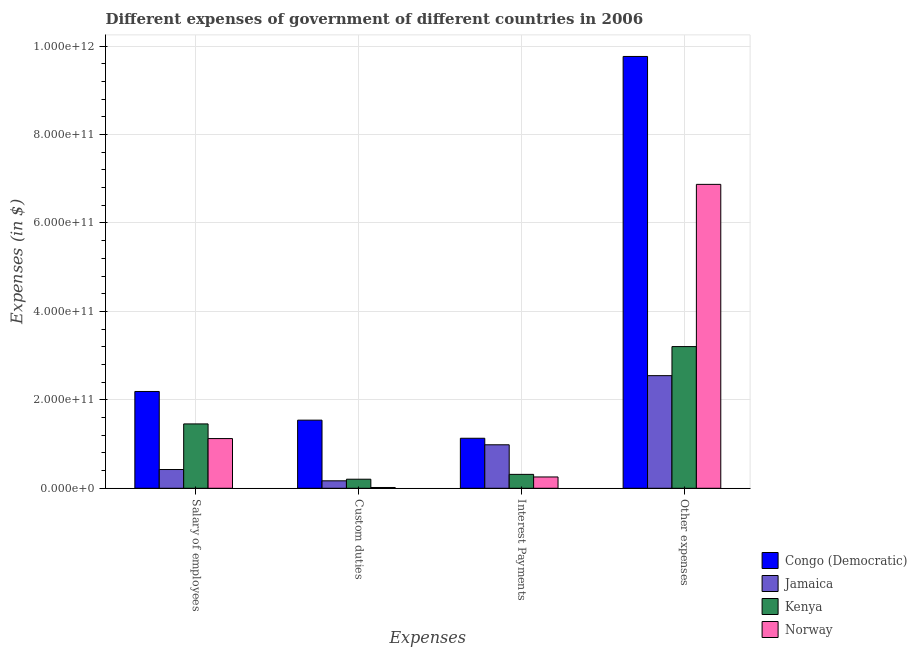Are the number of bars per tick equal to the number of legend labels?
Provide a short and direct response. Yes. How many bars are there on the 4th tick from the left?
Your response must be concise. 4. How many bars are there on the 4th tick from the right?
Keep it short and to the point. 4. What is the label of the 4th group of bars from the left?
Ensure brevity in your answer.  Other expenses. What is the amount spent on salary of employees in Norway?
Your answer should be compact. 1.12e+11. Across all countries, what is the maximum amount spent on interest payments?
Offer a very short reply. 1.13e+11. Across all countries, what is the minimum amount spent on other expenses?
Your response must be concise. 2.55e+11. In which country was the amount spent on custom duties maximum?
Your response must be concise. Congo (Democratic). What is the total amount spent on other expenses in the graph?
Give a very brief answer. 2.24e+12. What is the difference between the amount spent on interest payments in Congo (Democratic) and that in Norway?
Your response must be concise. 8.75e+1. What is the difference between the amount spent on other expenses in Kenya and the amount spent on interest payments in Norway?
Provide a succinct answer. 2.95e+11. What is the average amount spent on other expenses per country?
Offer a terse response. 5.60e+11. What is the difference between the amount spent on custom duties and amount spent on interest payments in Jamaica?
Make the answer very short. -8.15e+1. What is the ratio of the amount spent on custom duties in Jamaica to that in Norway?
Give a very brief answer. 9.43. What is the difference between the highest and the second highest amount spent on salary of employees?
Offer a very short reply. 7.34e+1. What is the difference between the highest and the lowest amount spent on custom duties?
Give a very brief answer. 1.52e+11. Is the sum of the amount spent on interest payments in Norway and Jamaica greater than the maximum amount spent on other expenses across all countries?
Make the answer very short. No. Is it the case that in every country, the sum of the amount spent on salary of employees and amount spent on custom duties is greater than the sum of amount spent on interest payments and amount spent on other expenses?
Your response must be concise. No. What does the 1st bar from the left in Interest Payments represents?
Ensure brevity in your answer.  Congo (Democratic). What does the 2nd bar from the right in Other expenses represents?
Keep it short and to the point. Kenya. Is it the case that in every country, the sum of the amount spent on salary of employees and amount spent on custom duties is greater than the amount spent on interest payments?
Your response must be concise. No. Are all the bars in the graph horizontal?
Offer a terse response. No. What is the difference between two consecutive major ticks on the Y-axis?
Make the answer very short. 2.00e+11. Are the values on the major ticks of Y-axis written in scientific E-notation?
Make the answer very short. Yes. Where does the legend appear in the graph?
Your answer should be very brief. Bottom right. How many legend labels are there?
Ensure brevity in your answer.  4. What is the title of the graph?
Provide a succinct answer. Different expenses of government of different countries in 2006. Does "Guinea-Bissau" appear as one of the legend labels in the graph?
Your response must be concise. No. What is the label or title of the X-axis?
Give a very brief answer. Expenses. What is the label or title of the Y-axis?
Give a very brief answer. Expenses (in $). What is the Expenses (in $) in Congo (Democratic) in Salary of employees?
Your answer should be very brief. 2.19e+11. What is the Expenses (in $) of Jamaica in Salary of employees?
Your response must be concise. 4.24e+1. What is the Expenses (in $) of Kenya in Salary of employees?
Offer a very short reply. 1.46e+11. What is the Expenses (in $) in Norway in Salary of employees?
Ensure brevity in your answer.  1.12e+11. What is the Expenses (in $) in Congo (Democratic) in Custom duties?
Provide a succinct answer. 1.54e+11. What is the Expenses (in $) in Jamaica in Custom duties?
Your answer should be very brief. 1.69e+1. What is the Expenses (in $) in Kenya in Custom duties?
Your answer should be compact. 2.05e+1. What is the Expenses (in $) of Norway in Custom duties?
Provide a succinct answer. 1.79e+09. What is the Expenses (in $) of Congo (Democratic) in Interest Payments?
Keep it short and to the point. 1.13e+11. What is the Expenses (in $) in Jamaica in Interest Payments?
Provide a succinct answer. 9.84e+1. What is the Expenses (in $) in Kenya in Interest Payments?
Offer a terse response. 3.15e+1. What is the Expenses (in $) of Norway in Interest Payments?
Your answer should be very brief. 2.56e+1. What is the Expenses (in $) in Congo (Democratic) in Other expenses?
Provide a succinct answer. 9.76e+11. What is the Expenses (in $) of Jamaica in Other expenses?
Ensure brevity in your answer.  2.55e+11. What is the Expenses (in $) of Kenya in Other expenses?
Your answer should be compact. 3.20e+11. What is the Expenses (in $) in Norway in Other expenses?
Your response must be concise. 6.87e+11. Across all Expenses, what is the maximum Expenses (in $) of Congo (Democratic)?
Make the answer very short. 9.76e+11. Across all Expenses, what is the maximum Expenses (in $) in Jamaica?
Your answer should be very brief. 2.55e+11. Across all Expenses, what is the maximum Expenses (in $) in Kenya?
Provide a succinct answer. 3.20e+11. Across all Expenses, what is the maximum Expenses (in $) of Norway?
Provide a short and direct response. 6.87e+11. Across all Expenses, what is the minimum Expenses (in $) in Congo (Democratic)?
Give a very brief answer. 1.13e+11. Across all Expenses, what is the minimum Expenses (in $) in Jamaica?
Provide a short and direct response. 1.69e+1. Across all Expenses, what is the minimum Expenses (in $) of Kenya?
Your answer should be very brief. 2.05e+1. Across all Expenses, what is the minimum Expenses (in $) in Norway?
Ensure brevity in your answer.  1.79e+09. What is the total Expenses (in $) in Congo (Democratic) in the graph?
Offer a very short reply. 1.46e+12. What is the total Expenses (in $) in Jamaica in the graph?
Give a very brief answer. 4.12e+11. What is the total Expenses (in $) in Kenya in the graph?
Provide a short and direct response. 5.18e+11. What is the total Expenses (in $) of Norway in the graph?
Offer a very short reply. 8.27e+11. What is the difference between the Expenses (in $) in Congo (Democratic) in Salary of employees and that in Custom duties?
Give a very brief answer. 6.49e+1. What is the difference between the Expenses (in $) in Jamaica in Salary of employees and that in Custom duties?
Keep it short and to the point. 2.55e+1. What is the difference between the Expenses (in $) of Kenya in Salary of employees and that in Custom duties?
Your response must be concise. 1.25e+11. What is the difference between the Expenses (in $) of Norway in Salary of employees and that in Custom duties?
Provide a short and direct response. 1.11e+11. What is the difference between the Expenses (in $) in Congo (Democratic) in Salary of employees and that in Interest Payments?
Provide a succinct answer. 1.06e+11. What is the difference between the Expenses (in $) in Jamaica in Salary of employees and that in Interest Payments?
Offer a very short reply. -5.59e+1. What is the difference between the Expenses (in $) of Kenya in Salary of employees and that in Interest Payments?
Provide a succinct answer. 1.14e+11. What is the difference between the Expenses (in $) of Norway in Salary of employees and that in Interest Payments?
Provide a short and direct response. 8.68e+1. What is the difference between the Expenses (in $) of Congo (Democratic) in Salary of employees and that in Other expenses?
Your answer should be compact. -7.58e+11. What is the difference between the Expenses (in $) of Jamaica in Salary of employees and that in Other expenses?
Provide a short and direct response. -2.12e+11. What is the difference between the Expenses (in $) in Kenya in Salary of employees and that in Other expenses?
Your answer should be compact. -1.75e+11. What is the difference between the Expenses (in $) in Norway in Salary of employees and that in Other expenses?
Give a very brief answer. -5.75e+11. What is the difference between the Expenses (in $) of Congo (Democratic) in Custom duties and that in Interest Payments?
Give a very brief answer. 4.09e+1. What is the difference between the Expenses (in $) in Jamaica in Custom duties and that in Interest Payments?
Make the answer very short. -8.15e+1. What is the difference between the Expenses (in $) in Kenya in Custom duties and that in Interest Payments?
Provide a short and direct response. -1.09e+1. What is the difference between the Expenses (in $) of Norway in Custom duties and that in Interest Payments?
Keep it short and to the point. -2.38e+1. What is the difference between the Expenses (in $) in Congo (Democratic) in Custom duties and that in Other expenses?
Your answer should be very brief. -8.22e+11. What is the difference between the Expenses (in $) in Jamaica in Custom duties and that in Other expenses?
Keep it short and to the point. -2.38e+11. What is the difference between the Expenses (in $) in Kenya in Custom duties and that in Other expenses?
Make the answer very short. -3.00e+11. What is the difference between the Expenses (in $) in Norway in Custom duties and that in Other expenses?
Ensure brevity in your answer.  -6.85e+11. What is the difference between the Expenses (in $) of Congo (Democratic) in Interest Payments and that in Other expenses?
Make the answer very short. -8.63e+11. What is the difference between the Expenses (in $) in Jamaica in Interest Payments and that in Other expenses?
Provide a succinct answer. -1.56e+11. What is the difference between the Expenses (in $) in Kenya in Interest Payments and that in Other expenses?
Provide a short and direct response. -2.89e+11. What is the difference between the Expenses (in $) in Norway in Interest Payments and that in Other expenses?
Provide a short and direct response. -6.62e+11. What is the difference between the Expenses (in $) of Congo (Democratic) in Salary of employees and the Expenses (in $) of Jamaica in Custom duties?
Offer a very short reply. 2.02e+11. What is the difference between the Expenses (in $) of Congo (Democratic) in Salary of employees and the Expenses (in $) of Kenya in Custom duties?
Ensure brevity in your answer.  1.98e+11. What is the difference between the Expenses (in $) in Congo (Democratic) in Salary of employees and the Expenses (in $) in Norway in Custom duties?
Offer a terse response. 2.17e+11. What is the difference between the Expenses (in $) in Jamaica in Salary of employees and the Expenses (in $) in Kenya in Custom duties?
Your response must be concise. 2.19e+1. What is the difference between the Expenses (in $) of Jamaica in Salary of employees and the Expenses (in $) of Norway in Custom duties?
Offer a very short reply. 4.06e+1. What is the difference between the Expenses (in $) in Kenya in Salary of employees and the Expenses (in $) in Norway in Custom duties?
Make the answer very short. 1.44e+11. What is the difference between the Expenses (in $) of Congo (Democratic) in Salary of employees and the Expenses (in $) of Jamaica in Interest Payments?
Give a very brief answer. 1.21e+11. What is the difference between the Expenses (in $) in Congo (Democratic) in Salary of employees and the Expenses (in $) in Kenya in Interest Payments?
Offer a very short reply. 1.87e+11. What is the difference between the Expenses (in $) of Congo (Democratic) in Salary of employees and the Expenses (in $) of Norway in Interest Payments?
Your answer should be very brief. 1.93e+11. What is the difference between the Expenses (in $) in Jamaica in Salary of employees and the Expenses (in $) in Kenya in Interest Payments?
Provide a succinct answer. 1.10e+1. What is the difference between the Expenses (in $) in Jamaica in Salary of employees and the Expenses (in $) in Norway in Interest Payments?
Make the answer very short. 1.68e+1. What is the difference between the Expenses (in $) in Kenya in Salary of employees and the Expenses (in $) in Norway in Interest Payments?
Offer a very short reply. 1.20e+11. What is the difference between the Expenses (in $) in Congo (Democratic) in Salary of employees and the Expenses (in $) in Jamaica in Other expenses?
Make the answer very short. -3.58e+1. What is the difference between the Expenses (in $) in Congo (Democratic) in Salary of employees and the Expenses (in $) in Kenya in Other expenses?
Keep it short and to the point. -1.02e+11. What is the difference between the Expenses (in $) of Congo (Democratic) in Salary of employees and the Expenses (in $) of Norway in Other expenses?
Your response must be concise. -4.68e+11. What is the difference between the Expenses (in $) in Jamaica in Salary of employees and the Expenses (in $) in Kenya in Other expenses?
Provide a succinct answer. -2.78e+11. What is the difference between the Expenses (in $) of Jamaica in Salary of employees and the Expenses (in $) of Norway in Other expenses?
Give a very brief answer. -6.45e+11. What is the difference between the Expenses (in $) of Kenya in Salary of employees and the Expenses (in $) of Norway in Other expenses?
Your answer should be very brief. -5.42e+11. What is the difference between the Expenses (in $) of Congo (Democratic) in Custom duties and the Expenses (in $) of Jamaica in Interest Payments?
Provide a succinct answer. 5.57e+1. What is the difference between the Expenses (in $) in Congo (Democratic) in Custom duties and the Expenses (in $) in Kenya in Interest Payments?
Make the answer very short. 1.23e+11. What is the difference between the Expenses (in $) in Congo (Democratic) in Custom duties and the Expenses (in $) in Norway in Interest Payments?
Offer a very short reply. 1.28e+11. What is the difference between the Expenses (in $) of Jamaica in Custom duties and the Expenses (in $) of Kenya in Interest Payments?
Give a very brief answer. -1.46e+1. What is the difference between the Expenses (in $) of Jamaica in Custom duties and the Expenses (in $) of Norway in Interest Payments?
Keep it short and to the point. -8.71e+09. What is the difference between the Expenses (in $) of Kenya in Custom duties and the Expenses (in $) of Norway in Interest Payments?
Offer a very short reply. -5.08e+09. What is the difference between the Expenses (in $) in Congo (Democratic) in Custom duties and the Expenses (in $) in Jamaica in Other expenses?
Offer a terse response. -1.01e+11. What is the difference between the Expenses (in $) in Congo (Democratic) in Custom duties and the Expenses (in $) in Kenya in Other expenses?
Ensure brevity in your answer.  -1.66e+11. What is the difference between the Expenses (in $) of Congo (Democratic) in Custom duties and the Expenses (in $) of Norway in Other expenses?
Your response must be concise. -5.33e+11. What is the difference between the Expenses (in $) of Jamaica in Custom duties and the Expenses (in $) of Kenya in Other expenses?
Offer a very short reply. -3.04e+11. What is the difference between the Expenses (in $) of Jamaica in Custom duties and the Expenses (in $) of Norway in Other expenses?
Your answer should be very brief. -6.70e+11. What is the difference between the Expenses (in $) of Kenya in Custom duties and the Expenses (in $) of Norway in Other expenses?
Make the answer very short. -6.67e+11. What is the difference between the Expenses (in $) of Congo (Democratic) in Interest Payments and the Expenses (in $) of Jamaica in Other expenses?
Offer a very short reply. -1.42e+11. What is the difference between the Expenses (in $) in Congo (Democratic) in Interest Payments and the Expenses (in $) in Kenya in Other expenses?
Ensure brevity in your answer.  -2.07e+11. What is the difference between the Expenses (in $) in Congo (Democratic) in Interest Payments and the Expenses (in $) in Norway in Other expenses?
Provide a short and direct response. -5.74e+11. What is the difference between the Expenses (in $) of Jamaica in Interest Payments and the Expenses (in $) of Kenya in Other expenses?
Keep it short and to the point. -2.22e+11. What is the difference between the Expenses (in $) in Jamaica in Interest Payments and the Expenses (in $) in Norway in Other expenses?
Your answer should be very brief. -5.89e+11. What is the difference between the Expenses (in $) in Kenya in Interest Payments and the Expenses (in $) in Norway in Other expenses?
Keep it short and to the point. -6.56e+11. What is the average Expenses (in $) in Congo (Democratic) per Expenses?
Keep it short and to the point. 3.66e+11. What is the average Expenses (in $) in Jamaica per Expenses?
Provide a short and direct response. 1.03e+11. What is the average Expenses (in $) of Kenya per Expenses?
Make the answer very short. 1.29e+11. What is the average Expenses (in $) in Norway per Expenses?
Your answer should be very brief. 2.07e+11. What is the difference between the Expenses (in $) of Congo (Democratic) and Expenses (in $) of Jamaica in Salary of employees?
Your answer should be very brief. 1.76e+11. What is the difference between the Expenses (in $) in Congo (Democratic) and Expenses (in $) in Kenya in Salary of employees?
Your answer should be very brief. 7.34e+1. What is the difference between the Expenses (in $) in Congo (Democratic) and Expenses (in $) in Norway in Salary of employees?
Your answer should be very brief. 1.06e+11. What is the difference between the Expenses (in $) in Jamaica and Expenses (in $) in Kenya in Salary of employees?
Your answer should be compact. -1.03e+11. What is the difference between the Expenses (in $) in Jamaica and Expenses (in $) in Norway in Salary of employees?
Give a very brief answer. -7.00e+1. What is the difference between the Expenses (in $) of Kenya and Expenses (in $) of Norway in Salary of employees?
Offer a very short reply. 3.31e+1. What is the difference between the Expenses (in $) in Congo (Democratic) and Expenses (in $) in Jamaica in Custom duties?
Offer a terse response. 1.37e+11. What is the difference between the Expenses (in $) of Congo (Democratic) and Expenses (in $) of Kenya in Custom duties?
Offer a terse response. 1.34e+11. What is the difference between the Expenses (in $) in Congo (Democratic) and Expenses (in $) in Norway in Custom duties?
Provide a short and direct response. 1.52e+11. What is the difference between the Expenses (in $) of Jamaica and Expenses (in $) of Kenya in Custom duties?
Provide a succinct answer. -3.63e+09. What is the difference between the Expenses (in $) in Jamaica and Expenses (in $) in Norway in Custom duties?
Keep it short and to the point. 1.51e+1. What is the difference between the Expenses (in $) of Kenya and Expenses (in $) of Norway in Custom duties?
Offer a terse response. 1.87e+1. What is the difference between the Expenses (in $) in Congo (Democratic) and Expenses (in $) in Jamaica in Interest Payments?
Your answer should be compact. 1.47e+1. What is the difference between the Expenses (in $) of Congo (Democratic) and Expenses (in $) of Kenya in Interest Payments?
Offer a very short reply. 8.16e+1. What is the difference between the Expenses (in $) in Congo (Democratic) and Expenses (in $) in Norway in Interest Payments?
Make the answer very short. 8.75e+1. What is the difference between the Expenses (in $) in Jamaica and Expenses (in $) in Kenya in Interest Payments?
Provide a short and direct response. 6.69e+1. What is the difference between the Expenses (in $) of Jamaica and Expenses (in $) of Norway in Interest Payments?
Your answer should be compact. 7.28e+1. What is the difference between the Expenses (in $) in Kenya and Expenses (in $) in Norway in Interest Payments?
Your response must be concise. 5.86e+09. What is the difference between the Expenses (in $) in Congo (Democratic) and Expenses (in $) in Jamaica in Other expenses?
Keep it short and to the point. 7.22e+11. What is the difference between the Expenses (in $) of Congo (Democratic) and Expenses (in $) of Kenya in Other expenses?
Offer a terse response. 6.56e+11. What is the difference between the Expenses (in $) in Congo (Democratic) and Expenses (in $) in Norway in Other expenses?
Keep it short and to the point. 2.89e+11. What is the difference between the Expenses (in $) in Jamaica and Expenses (in $) in Kenya in Other expenses?
Offer a very short reply. -6.57e+1. What is the difference between the Expenses (in $) in Jamaica and Expenses (in $) in Norway in Other expenses?
Provide a succinct answer. -4.32e+11. What is the difference between the Expenses (in $) of Kenya and Expenses (in $) of Norway in Other expenses?
Keep it short and to the point. -3.67e+11. What is the ratio of the Expenses (in $) of Congo (Democratic) in Salary of employees to that in Custom duties?
Offer a very short reply. 1.42. What is the ratio of the Expenses (in $) of Jamaica in Salary of employees to that in Custom duties?
Offer a terse response. 2.51. What is the ratio of the Expenses (in $) in Kenya in Salary of employees to that in Custom duties?
Offer a very short reply. 7.1. What is the ratio of the Expenses (in $) of Norway in Salary of employees to that in Custom duties?
Your answer should be compact. 62.8. What is the ratio of the Expenses (in $) of Congo (Democratic) in Salary of employees to that in Interest Payments?
Keep it short and to the point. 1.94. What is the ratio of the Expenses (in $) of Jamaica in Salary of employees to that in Interest Payments?
Your answer should be compact. 0.43. What is the ratio of the Expenses (in $) of Kenya in Salary of employees to that in Interest Payments?
Give a very brief answer. 4.63. What is the ratio of the Expenses (in $) in Norway in Salary of employees to that in Interest Payments?
Keep it short and to the point. 4.39. What is the ratio of the Expenses (in $) in Congo (Democratic) in Salary of employees to that in Other expenses?
Ensure brevity in your answer.  0.22. What is the ratio of the Expenses (in $) of Jamaica in Salary of employees to that in Other expenses?
Provide a short and direct response. 0.17. What is the ratio of the Expenses (in $) in Kenya in Salary of employees to that in Other expenses?
Keep it short and to the point. 0.45. What is the ratio of the Expenses (in $) in Norway in Salary of employees to that in Other expenses?
Your answer should be very brief. 0.16. What is the ratio of the Expenses (in $) in Congo (Democratic) in Custom duties to that in Interest Payments?
Offer a very short reply. 1.36. What is the ratio of the Expenses (in $) in Jamaica in Custom duties to that in Interest Payments?
Provide a succinct answer. 0.17. What is the ratio of the Expenses (in $) of Kenya in Custom duties to that in Interest Payments?
Keep it short and to the point. 0.65. What is the ratio of the Expenses (in $) of Norway in Custom duties to that in Interest Payments?
Keep it short and to the point. 0.07. What is the ratio of the Expenses (in $) of Congo (Democratic) in Custom duties to that in Other expenses?
Keep it short and to the point. 0.16. What is the ratio of the Expenses (in $) of Jamaica in Custom duties to that in Other expenses?
Offer a terse response. 0.07. What is the ratio of the Expenses (in $) of Kenya in Custom duties to that in Other expenses?
Keep it short and to the point. 0.06. What is the ratio of the Expenses (in $) in Norway in Custom duties to that in Other expenses?
Provide a short and direct response. 0. What is the ratio of the Expenses (in $) in Congo (Democratic) in Interest Payments to that in Other expenses?
Make the answer very short. 0.12. What is the ratio of the Expenses (in $) of Jamaica in Interest Payments to that in Other expenses?
Your answer should be very brief. 0.39. What is the ratio of the Expenses (in $) in Kenya in Interest Payments to that in Other expenses?
Give a very brief answer. 0.1. What is the ratio of the Expenses (in $) in Norway in Interest Payments to that in Other expenses?
Give a very brief answer. 0.04. What is the difference between the highest and the second highest Expenses (in $) in Congo (Democratic)?
Provide a short and direct response. 7.58e+11. What is the difference between the highest and the second highest Expenses (in $) in Jamaica?
Your response must be concise. 1.56e+11. What is the difference between the highest and the second highest Expenses (in $) of Kenya?
Offer a very short reply. 1.75e+11. What is the difference between the highest and the second highest Expenses (in $) in Norway?
Your answer should be very brief. 5.75e+11. What is the difference between the highest and the lowest Expenses (in $) of Congo (Democratic)?
Make the answer very short. 8.63e+11. What is the difference between the highest and the lowest Expenses (in $) in Jamaica?
Your answer should be very brief. 2.38e+11. What is the difference between the highest and the lowest Expenses (in $) of Kenya?
Your answer should be very brief. 3.00e+11. What is the difference between the highest and the lowest Expenses (in $) in Norway?
Make the answer very short. 6.85e+11. 